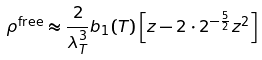Convert formula to latex. <formula><loc_0><loc_0><loc_500><loc_500>\rho ^ { \text {free} } \approx \frac { 2 } { \lambda _ { T } ^ { 3 } } b _ { 1 } ( T ) \left [ z - 2 \cdot 2 ^ { - \frac { 5 } { 2 } } z ^ { 2 } \right ]</formula> 